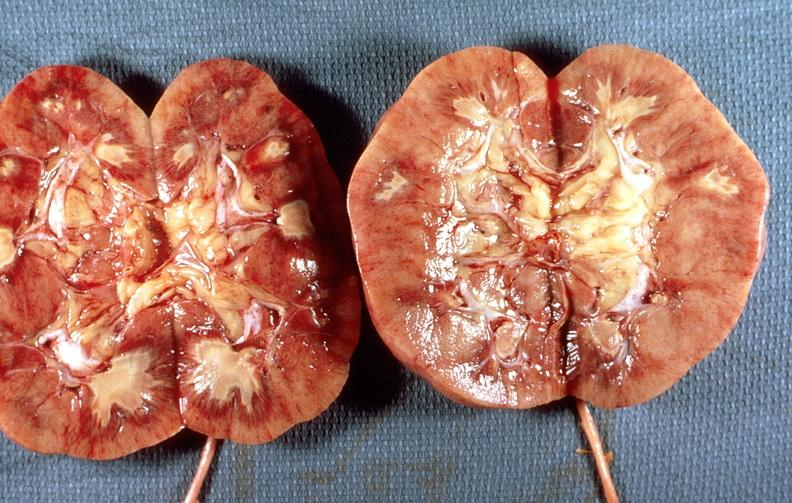does this image show renal papillary necrosis, diabetes mellitus dm?
Answer the question using a single word or phrase. Yes 